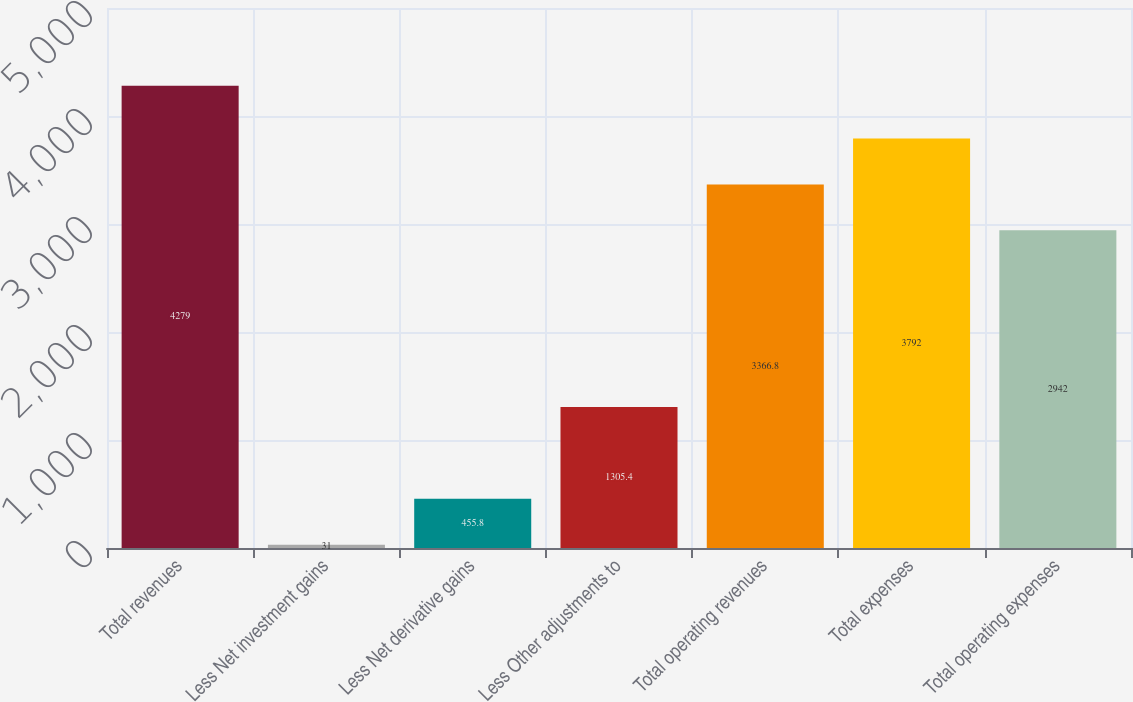Convert chart. <chart><loc_0><loc_0><loc_500><loc_500><bar_chart><fcel>Total revenues<fcel>Less Net investment gains<fcel>Less Net derivative gains<fcel>Less Other adjustments to<fcel>Total operating revenues<fcel>Total expenses<fcel>Total operating expenses<nl><fcel>4279<fcel>31<fcel>455.8<fcel>1305.4<fcel>3366.8<fcel>3792<fcel>2942<nl></chart> 